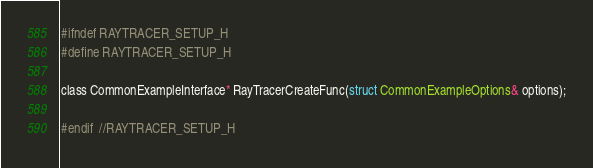<code> <loc_0><loc_0><loc_500><loc_500><_C_>#ifndef RAYTRACER_SETUP_H
#define RAYTRACER_SETUP_H

class CommonExampleInterface* RayTracerCreateFunc(struct CommonExampleOptions& options);

#endif  //RAYTRACER_SETUP_H
</code> 